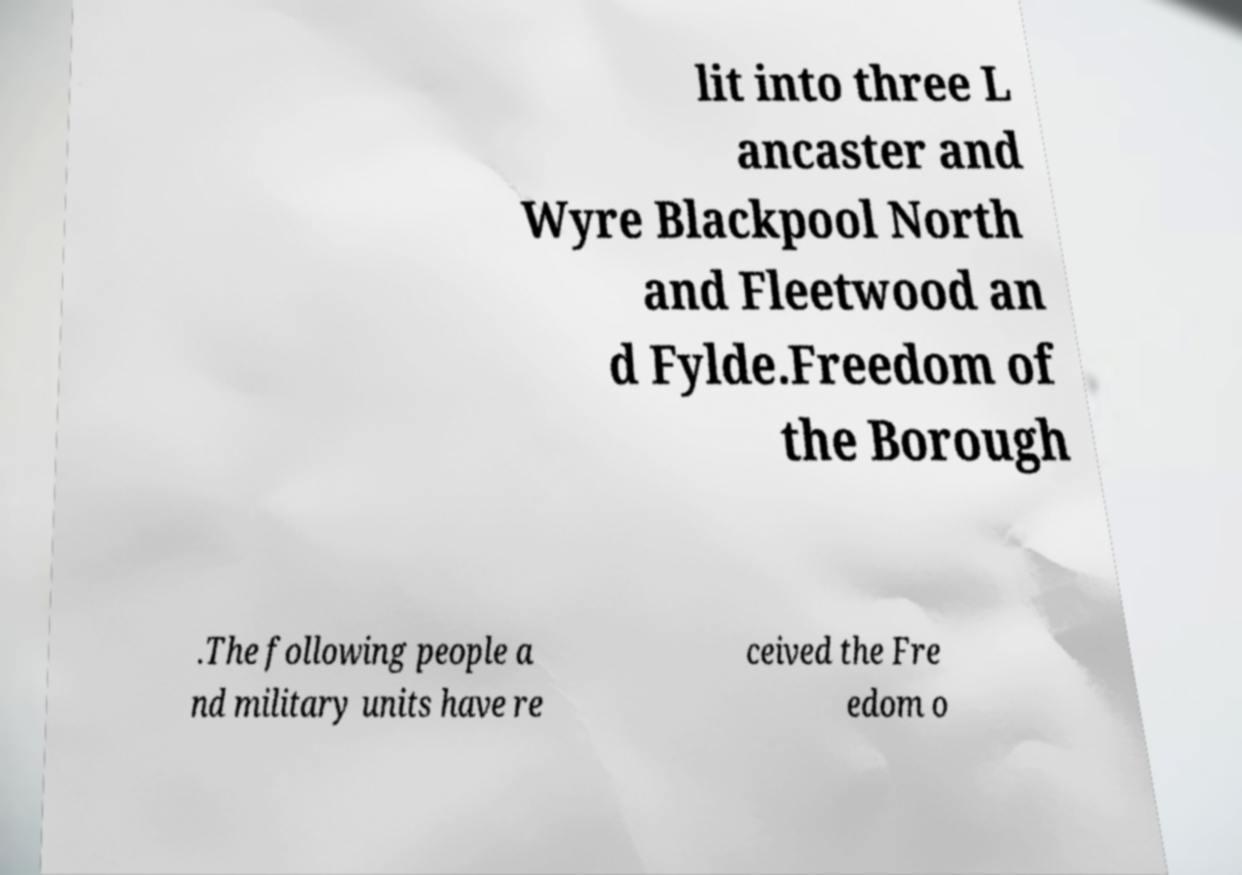Could you assist in decoding the text presented in this image and type it out clearly? lit into three L ancaster and Wyre Blackpool North and Fleetwood an d Fylde.Freedom of the Borough .The following people a nd military units have re ceived the Fre edom o 